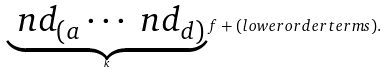<formula> <loc_0><loc_0><loc_500><loc_500>\underbrace { \ n d _ { ( a } \cdots \ n d _ { d ) } } _ { k } f + ( l o w e r o r d e r t e r m s ) .</formula> 